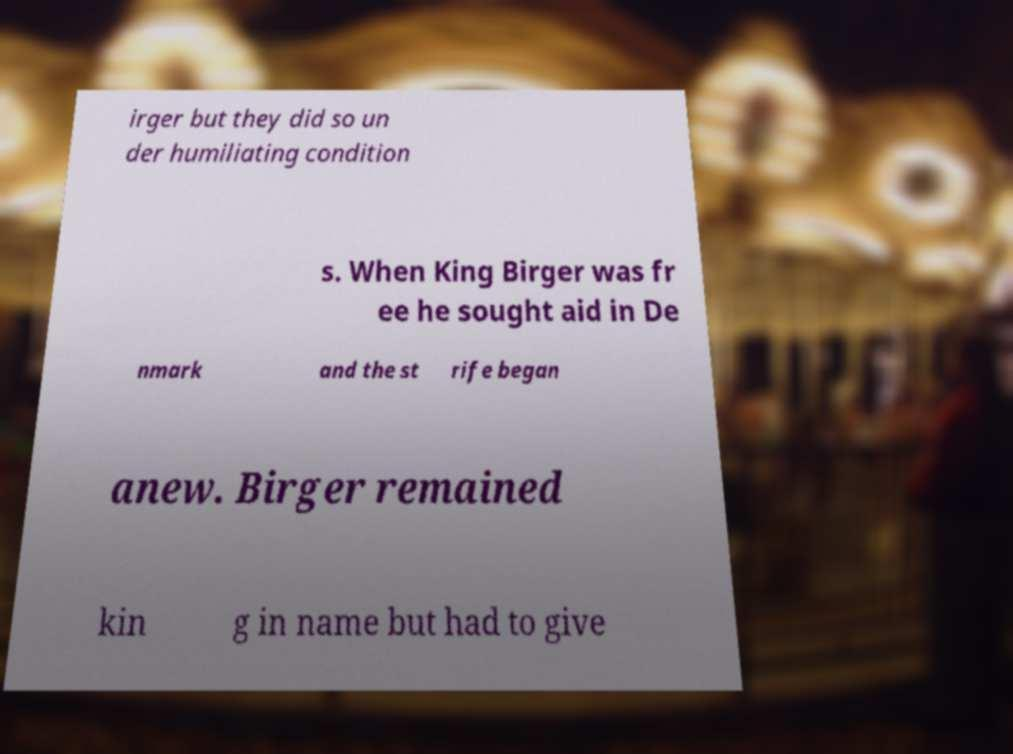Can you accurately transcribe the text from the provided image for me? irger but they did so un der humiliating condition s. When King Birger was fr ee he sought aid in De nmark and the st rife began anew. Birger remained kin g in name but had to give 